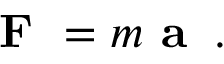<formula> <loc_0><loc_0><loc_500><loc_500>{ F } = m { a } \, .</formula> 